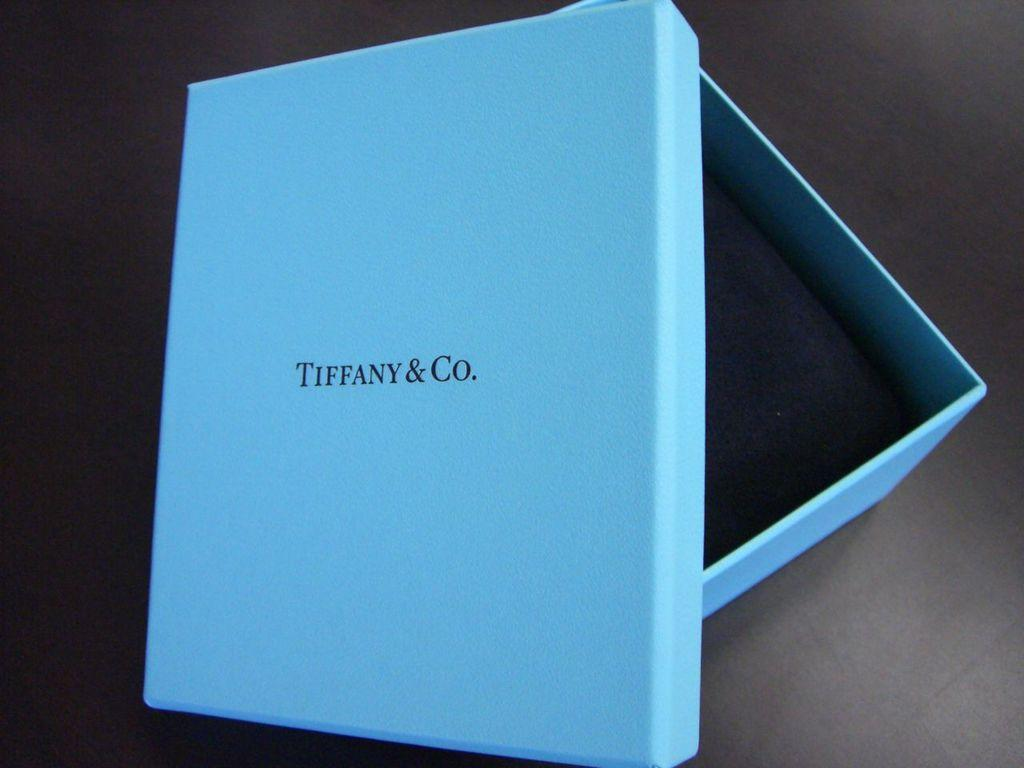<image>
Render a clear and concise summary of the photo. A blue box that is opened by Tiffany and Co. 